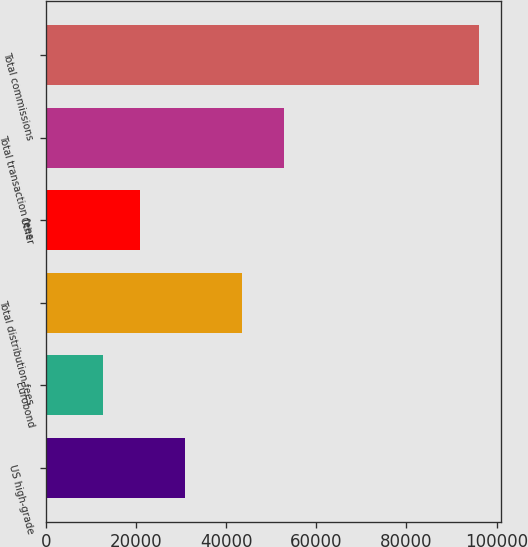<chart> <loc_0><loc_0><loc_500><loc_500><bar_chart><fcel>US high-grade<fcel>Eurobond<fcel>Total distribution fees<fcel>Other<fcel>Total transaction fees<fcel>Total commissions<nl><fcel>30831<fcel>12526<fcel>43357<fcel>20886.6<fcel>52775<fcel>96132<nl></chart> 